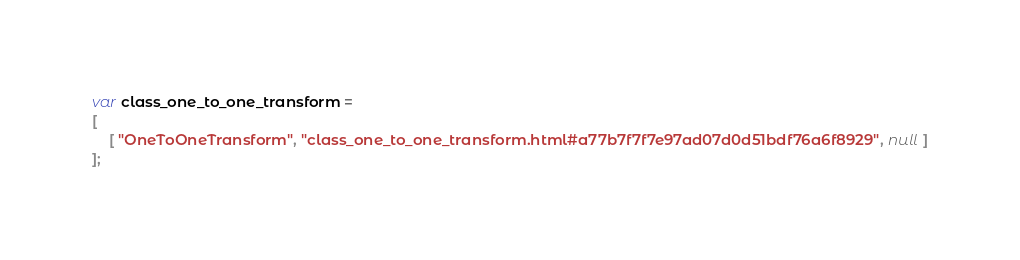<code> <loc_0><loc_0><loc_500><loc_500><_JavaScript_>var class_one_to_one_transform =
[
    [ "OneToOneTransform", "class_one_to_one_transform.html#a77b7f7f7e97ad07d0d51bdf76a6f8929", null ]
];</code> 